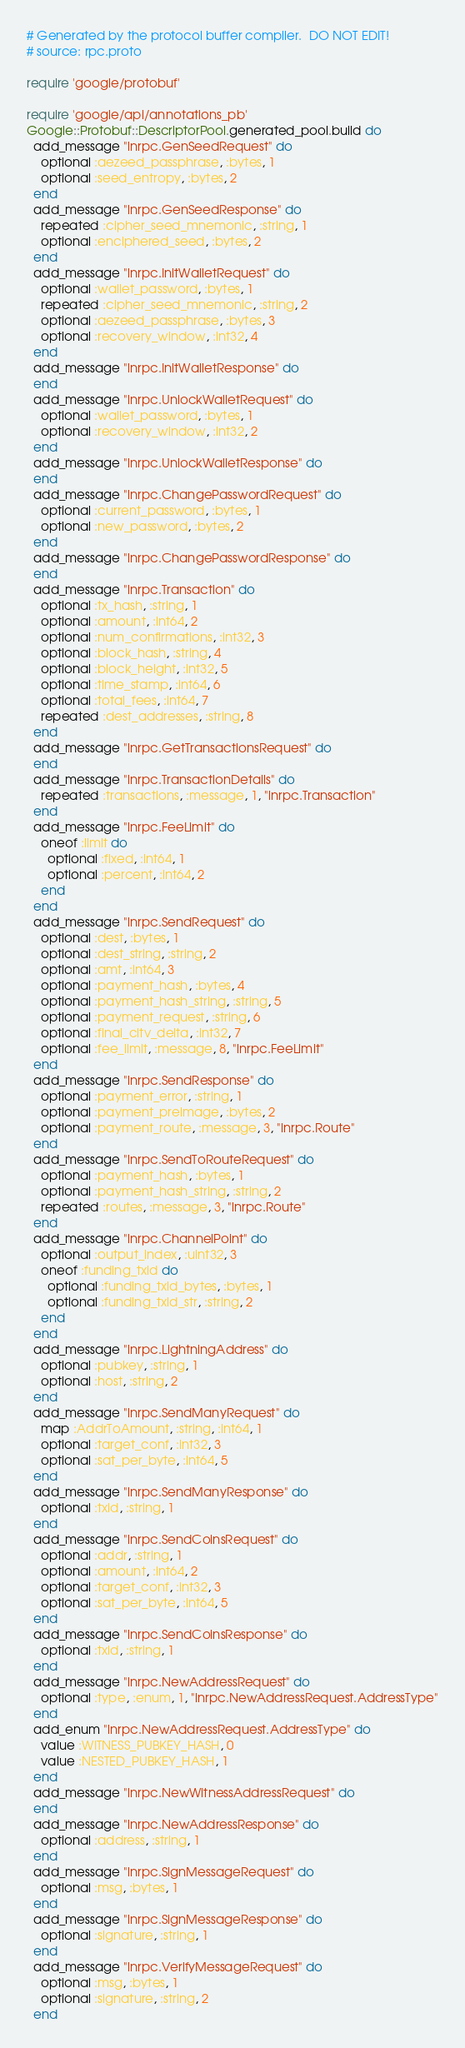<code> <loc_0><loc_0><loc_500><loc_500><_Ruby_># Generated by the protocol buffer compiler.  DO NOT EDIT!
# source: rpc.proto

require 'google/protobuf'

require 'google/api/annotations_pb'
Google::Protobuf::DescriptorPool.generated_pool.build do
  add_message "lnrpc.GenSeedRequest" do
    optional :aezeed_passphrase, :bytes, 1
    optional :seed_entropy, :bytes, 2
  end
  add_message "lnrpc.GenSeedResponse" do
    repeated :cipher_seed_mnemonic, :string, 1
    optional :enciphered_seed, :bytes, 2
  end
  add_message "lnrpc.InitWalletRequest" do
    optional :wallet_password, :bytes, 1
    repeated :cipher_seed_mnemonic, :string, 2
    optional :aezeed_passphrase, :bytes, 3
    optional :recovery_window, :int32, 4
  end
  add_message "lnrpc.InitWalletResponse" do
  end
  add_message "lnrpc.UnlockWalletRequest" do
    optional :wallet_password, :bytes, 1
    optional :recovery_window, :int32, 2
  end
  add_message "lnrpc.UnlockWalletResponse" do
  end
  add_message "lnrpc.ChangePasswordRequest" do
    optional :current_password, :bytes, 1
    optional :new_password, :bytes, 2
  end
  add_message "lnrpc.ChangePasswordResponse" do
  end
  add_message "lnrpc.Transaction" do
    optional :tx_hash, :string, 1
    optional :amount, :int64, 2
    optional :num_confirmations, :int32, 3
    optional :block_hash, :string, 4
    optional :block_height, :int32, 5
    optional :time_stamp, :int64, 6
    optional :total_fees, :int64, 7
    repeated :dest_addresses, :string, 8
  end
  add_message "lnrpc.GetTransactionsRequest" do
  end
  add_message "lnrpc.TransactionDetails" do
    repeated :transactions, :message, 1, "lnrpc.Transaction"
  end
  add_message "lnrpc.FeeLimit" do
    oneof :limit do
      optional :fixed, :int64, 1
      optional :percent, :int64, 2
    end
  end
  add_message "lnrpc.SendRequest" do
    optional :dest, :bytes, 1
    optional :dest_string, :string, 2
    optional :amt, :int64, 3
    optional :payment_hash, :bytes, 4
    optional :payment_hash_string, :string, 5
    optional :payment_request, :string, 6
    optional :final_cltv_delta, :int32, 7
    optional :fee_limit, :message, 8, "lnrpc.FeeLimit"
  end
  add_message "lnrpc.SendResponse" do
    optional :payment_error, :string, 1
    optional :payment_preimage, :bytes, 2
    optional :payment_route, :message, 3, "lnrpc.Route"
  end
  add_message "lnrpc.SendToRouteRequest" do
    optional :payment_hash, :bytes, 1
    optional :payment_hash_string, :string, 2
    repeated :routes, :message, 3, "lnrpc.Route"
  end
  add_message "lnrpc.ChannelPoint" do
    optional :output_index, :uint32, 3
    oneof :funding_txid do
      optional :funding_txid_bytes, :bytes, 1
      optional :funding_txid_str, :string, 2
    end
  end
  add_message "lnrpc.LightningAddress" do
    optional :pubkey, :string, 1
    optional :host, :string, 2
  end
  add_message "lnrpc.SendManyRequest" do
    map :AddrToAmount, :string, :int64, 1
    optional :target_conf, :int32, 3
    optional :sat_per_byte, :int64, 5
  end
  add_message "lnrpc.SendManyResponse" do
    optional :txid, :string, 1
  end
  add_message "lnrpc.SendCoinsRequest" do
    optional :addr, :string, 1
    optional :amount, :int64, 2
    optional :target_conf, :int32, 3
    optional :sat_per_byte, :int64, 5
  end
  add_message "lnrpc.SendCoinsResponse" do
    optional :txid, :string, 1
  end
  add_message "lnrpc.NewAddressRequest" do
    optional :type, :enum, 1, "lnrpc.NewAddressRequest.AddressType"
  end
  add_enum "lnrpc.NewAddressRequest.AddressType" do
    value :WITNESS_PUBKEY_HASH, 0
    value :NESTED_PUBKEY_HASH, 1
  end
  add_message "lnrpc.NewWitnessAddressRequest" do
  end
  add_message "lnrpc.NewAddressResponse" do
    optional :address, :string, 1
  end
  add_message "lnrpc.SignMessageRequest" do
    optional :msg, :bytes, 1
  end
  add_message "lnrpc.SignMessageResponse" do
    optional :signature, :string, 1
  end
  add_message "lnrpc.VerifyMessageRequest" do
    optional :msg, :bytes, 1
    optional :signature, :string, 2
  end</code> 